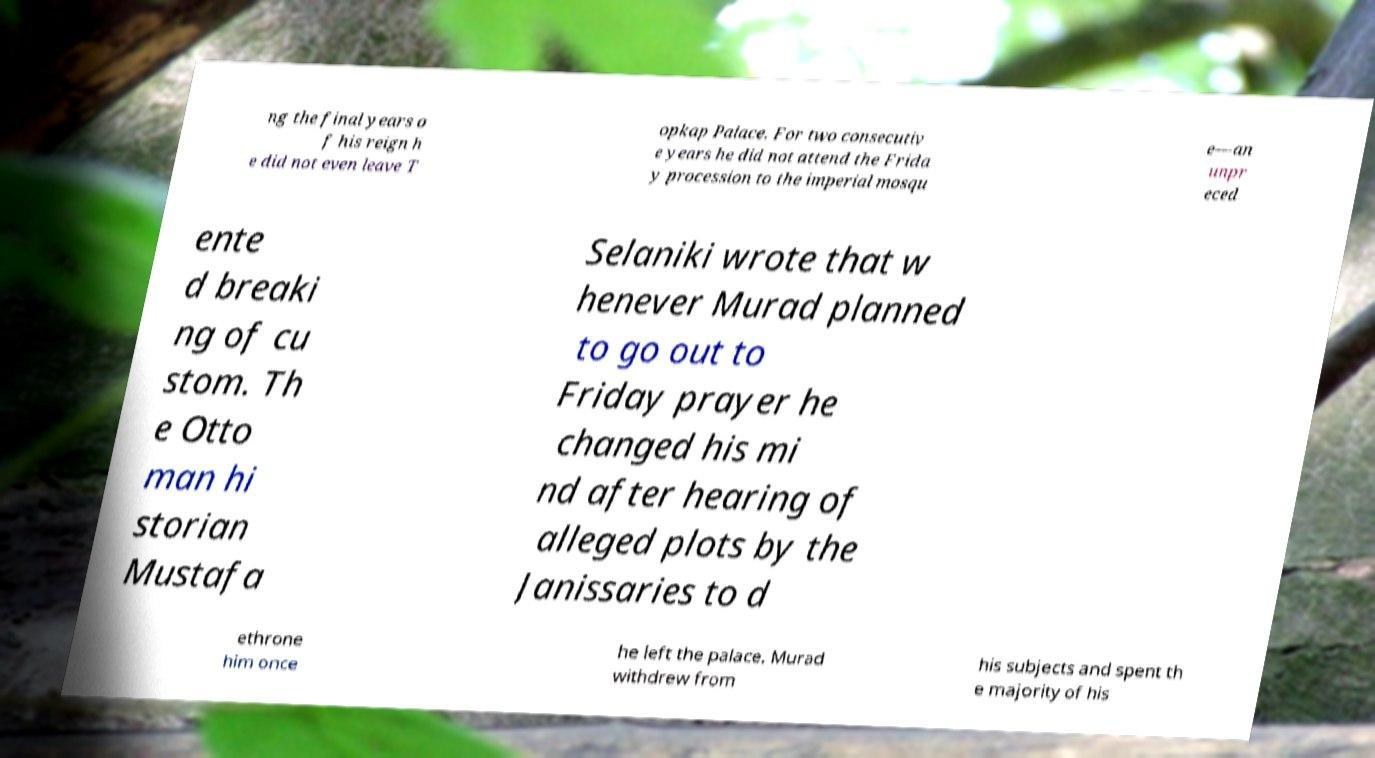There's text embedded in this image that I need extracted. Can you transcribe it verbatim? ng the final years o f his reign h e did not even leave T opkap Palace. For two consecutiv e years he did not attend the Frida y procession to the imperial mosqu e—an unpr eced ente d breaki ng of cu stom. Th e Otto man hi storian Mustafa Selaniki wrote that w henever Murad planned to go out to Friday prayer he changed his mi nd after hearing of alleged plots by the Janissaries to d ethrone him once he left the palace. Murad withdrew from his subjects and spent th e majority of his 